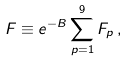<formula> <loc_0><loc_0><loc_500><loc_500>F \equiv e ^ { - B } \sum _ { p = 1 } ^ { 9 } F _ { p } \, ,</formula> 